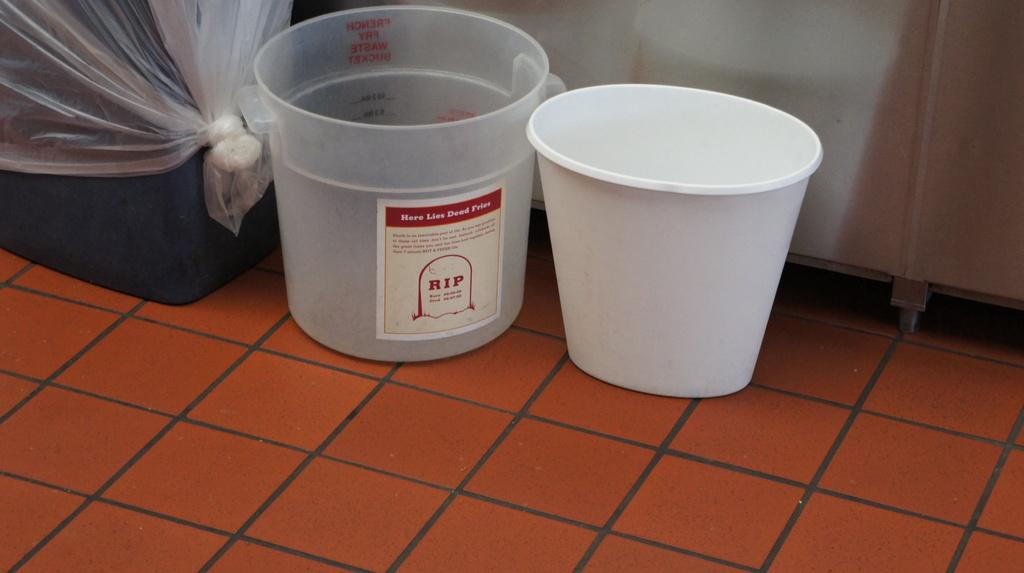Provide a one-sentence caption for the provided image. A plastic bucket that has RIP on the label. 